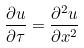Convert formula to latex. <formula><loc_0><loc_0><loc_500><loc_500>\frac { \partial u } { \partial \tau } = \frac { \partial ^ { 2 } u } { \partial x ^ { 2 } }</formula> 